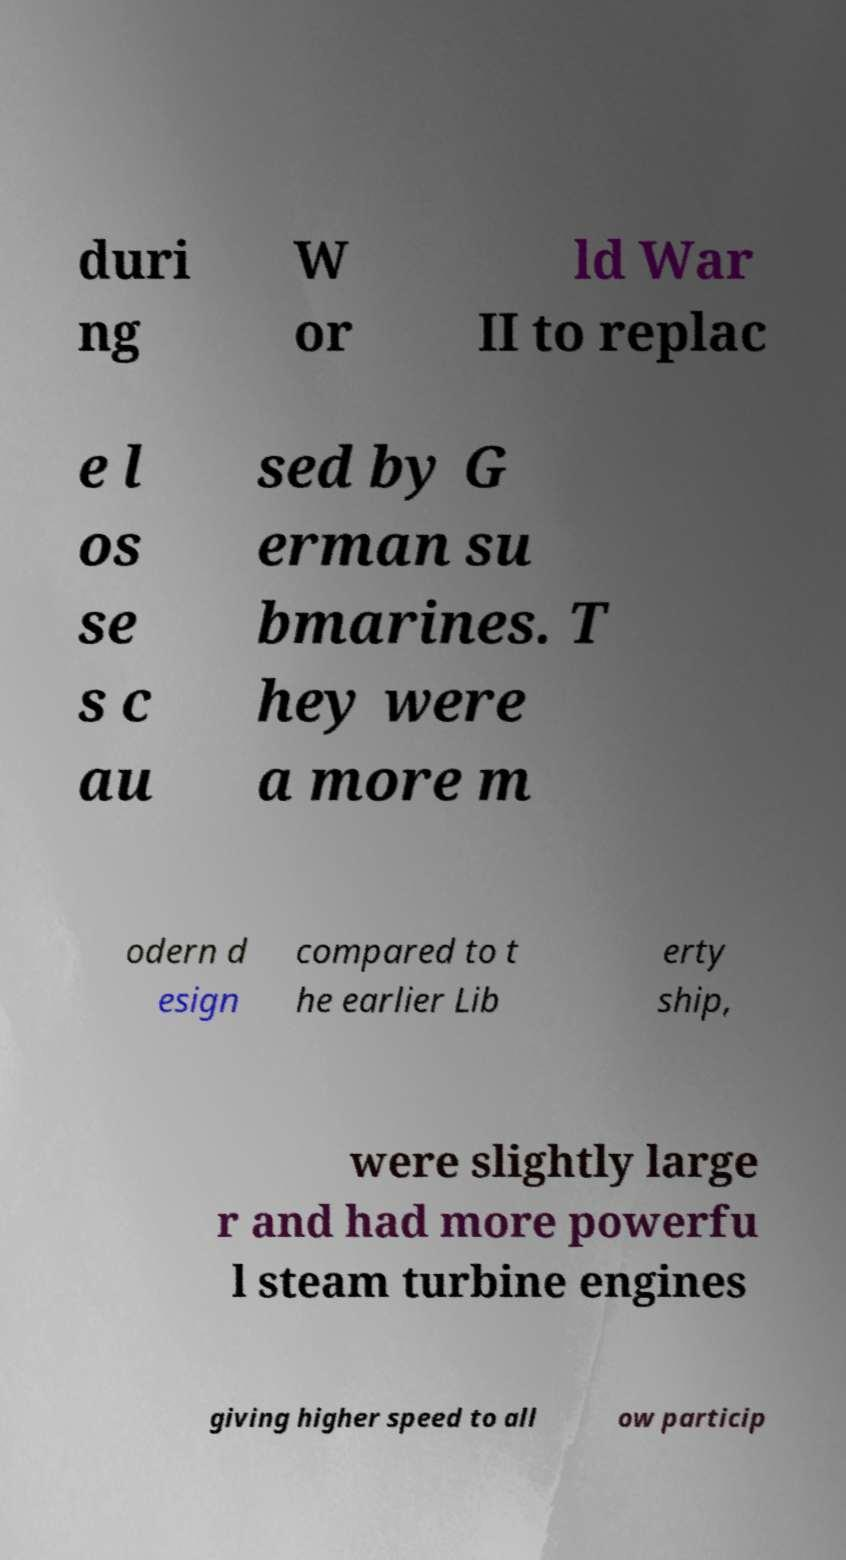I need the written content from this picture converted into text. Can you do that? duri ng W or ld War II to replac e l os se s c au sed by G erman su bmarines. T hey were a more m odern d esign compared to t he earlier Lib erty ship, were slightly large r and had more powerfu l steam turbine engines giving higher speed to all ow particip 